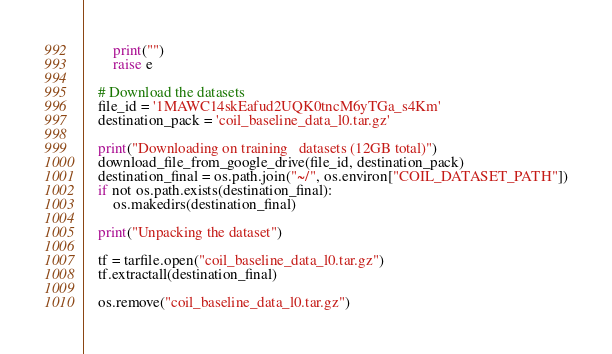<code> <loc_0><loc_0><loc_500><loc_500><_Python_>        print("")
        raise e

    # Download the datasets
    file_id = '1MAWC14skEafud2UQK0tncM6yTGa_s4Km'
    destination_pack = 'coil_baseline_data_l0.tar.gz'

    print("Downloading on training   datasets (12GB total)")
    download_file_from_google_drive(file_id, destination_pack)
    destination_final = os.path.join("~/", os.environ["COIL_DATASET_PATH"])
    if not os.path.exists(destination_final):
        os.makedirs(destination_final)

    print("Unpacking the dataset")

    tf = tarfile.open("coil_baseline_data_l0.tar.gz")
    tf.extractall(destination_final)

    os.remove("coil_baseline_data_l0.tar.gz")
</code> 